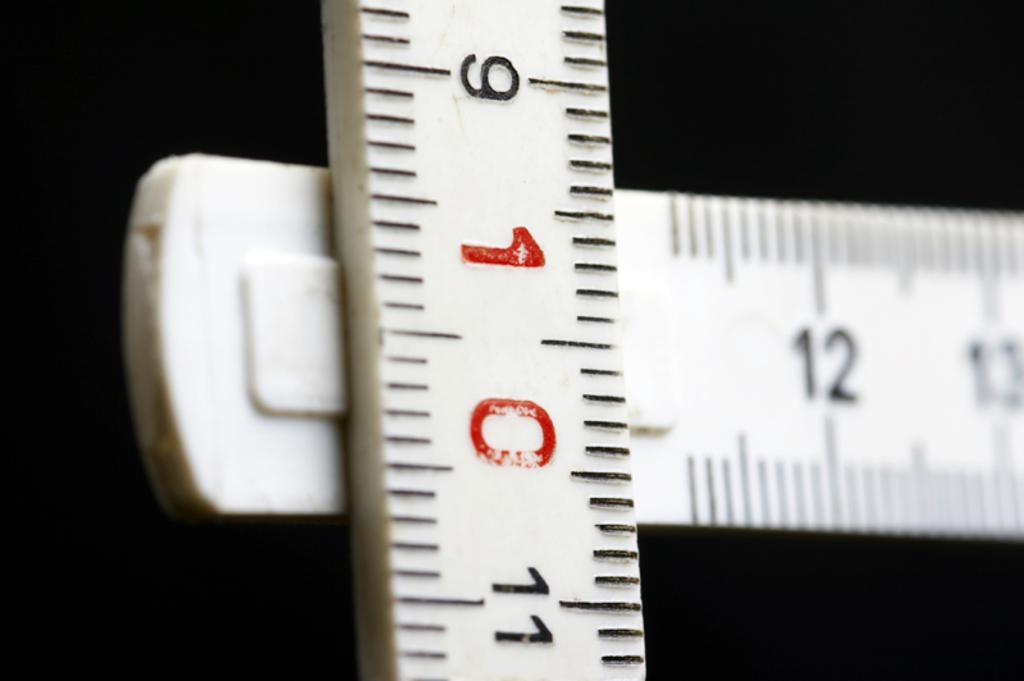Provide a one-sentence caption for the provided image. a white ruler T-square displaying 12 and 10 inches. 